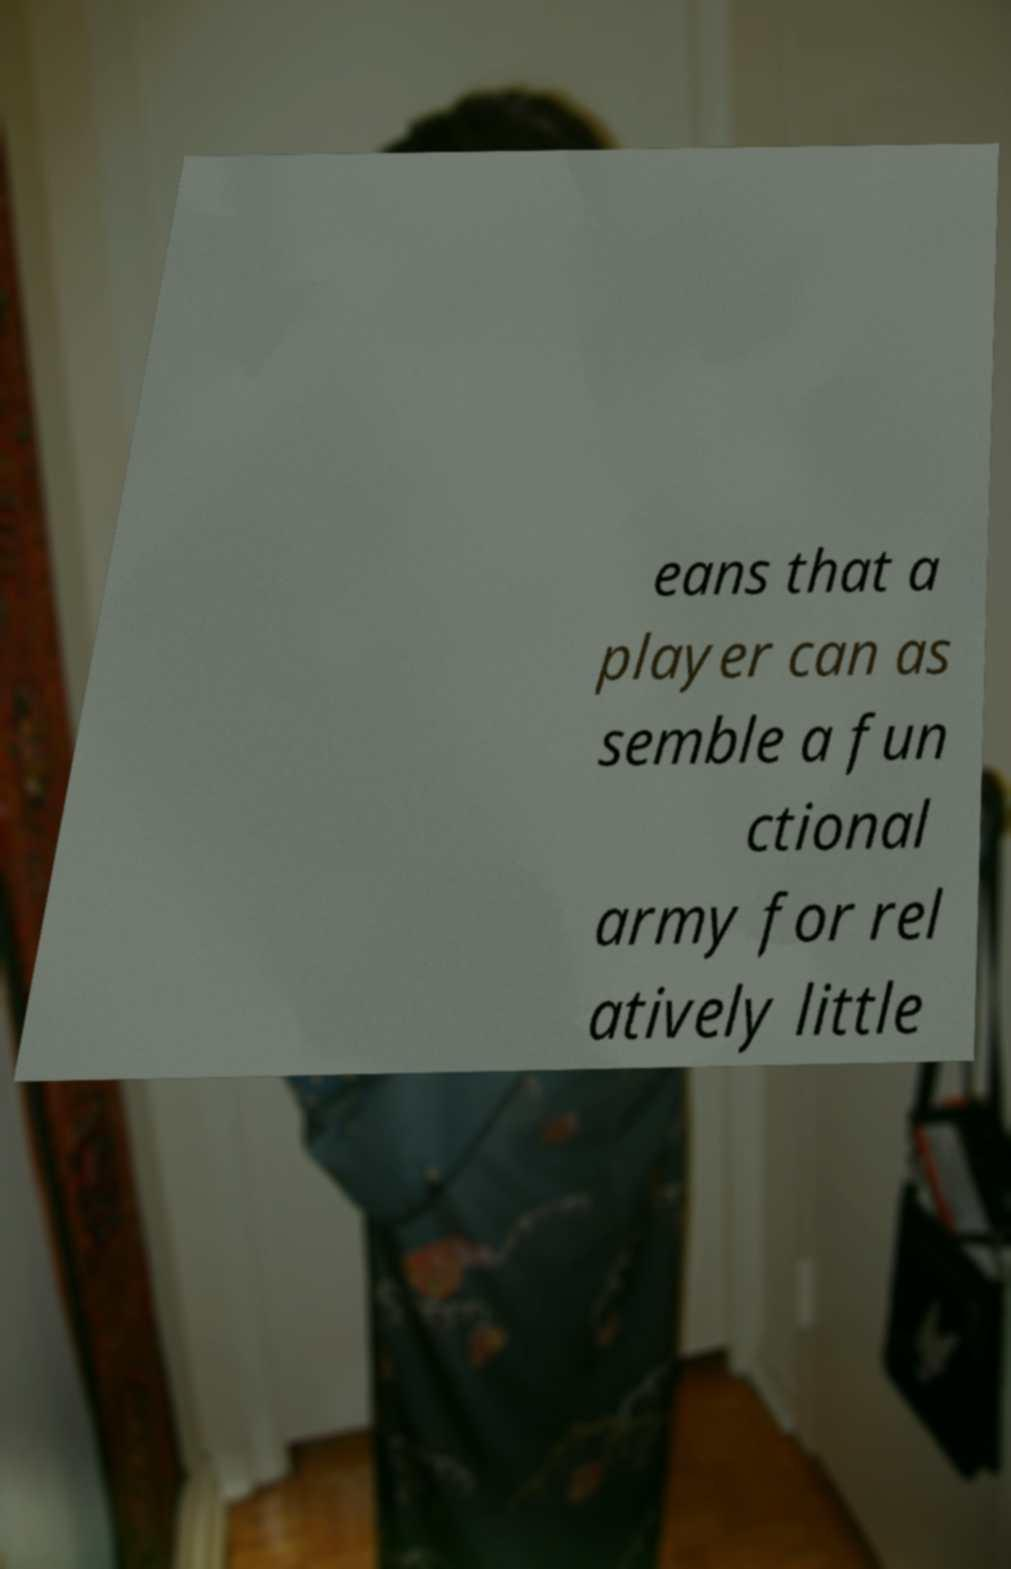Please identify and transcribe the text found in this image. eans that a player can as semble a fun ctional army for rel atively little 